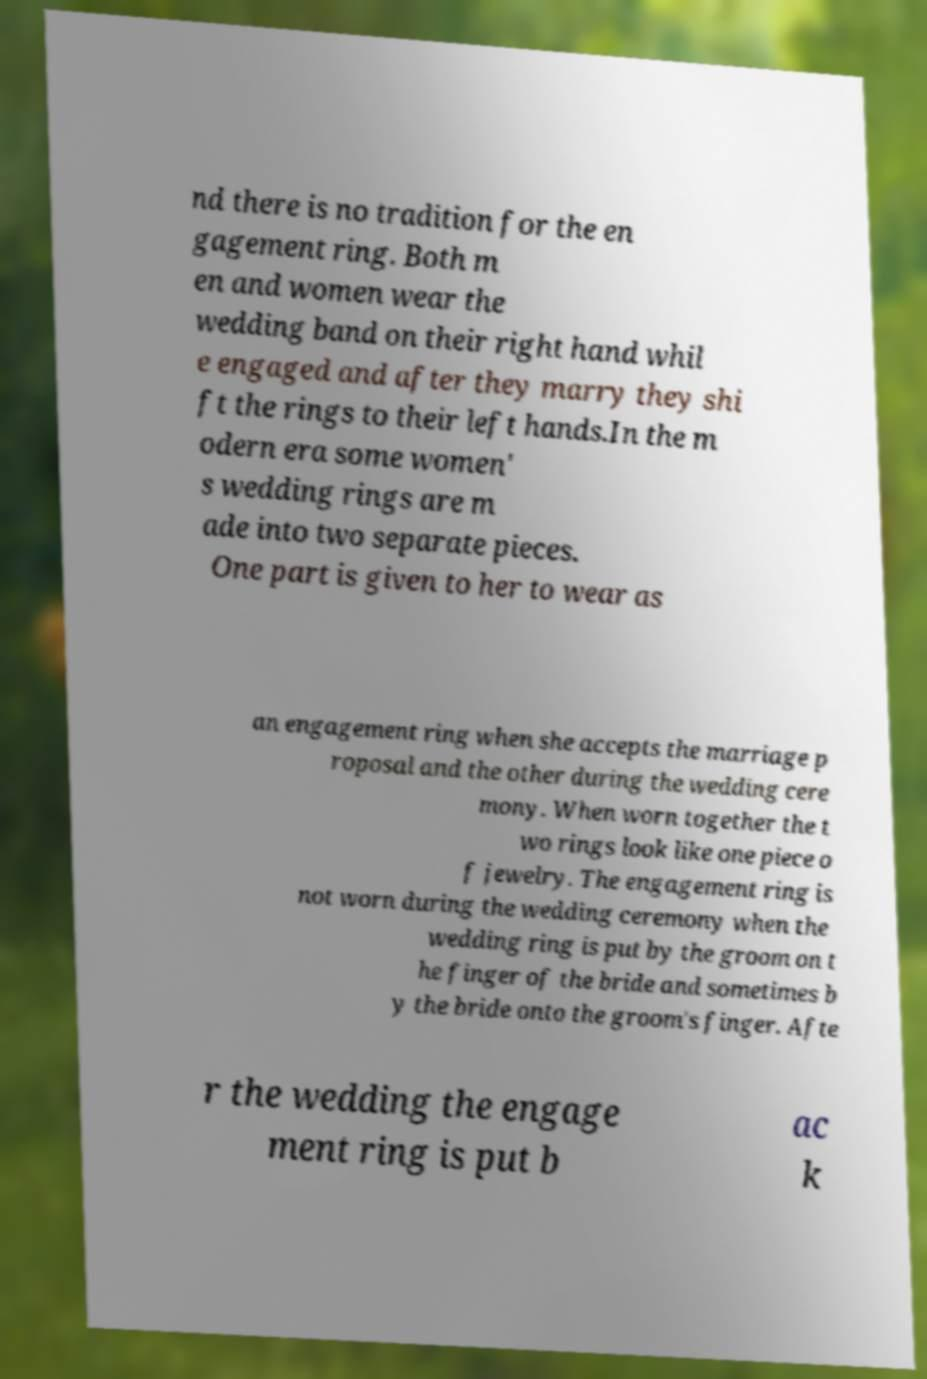Could you assist in decoding the text presented in this image and type it out clearly? nd there is no tradition for the en gagement ring. Both m en and women wear the wedding band on their right hand whil e engaged and after they marry they shi ft the rings to their left hands.In the m odern era some women' s wedding rings are m ade into two separate pieces. One part is given to her to wear as an engagement ring when she accepts the marriage p roposal and the other during the wedding cere mony. When worn together the t wo rings look like one piece o f jewelry. The engagement ring is not worn during the wedding ceremony when the wedding ring is put by the groom on t he finger of the bride and sometimes b y the bride onto the groom's finger. Afte r the wedding the engage ment ring is put b ac k 